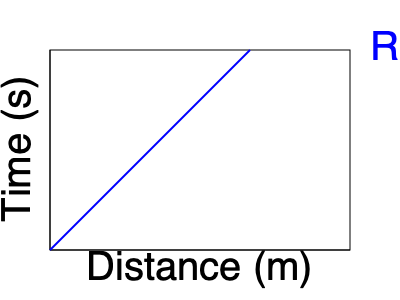As you swim along the river, you notice the water's speed seems constant. Using the graph of distance vs. time for the river's flow, calculate the speed of the water in meters per second. How fast could you travel downstream without swimming? To find the speed of the water flow, we need to calculate the slope of the line in the distance-time graph. Here's how we can do it:

1. Identify two points on the line. Let's choose:
   Point A: (0 m, 0 s)
   Point B: (200 m, 8 s)

2. Calculate the change in distance (Δd):
   Δd = 200 m - 0 m = 200 m

3. Calculate the change in time (Δt):
   Δt = 8 s - 0 s = 8 s

4. Use the formula for speed: 
   $$ \text{Speed} = \frac{\text{Change in distance}}{\text{Change in time}} = \frac{\Delta d}{\Delta t} $$

5. Plug in the values:
   $$ \text{Speed} = \frac{200 \text{ m}}{8 \text{ s}} = 25 \text{ m/s} $$

Therefore, the speed of the water flow is 25 meters per second. This is also how fast you could travel downstream without swimming, simply floating along with the current.
Answer: 25 m/s 